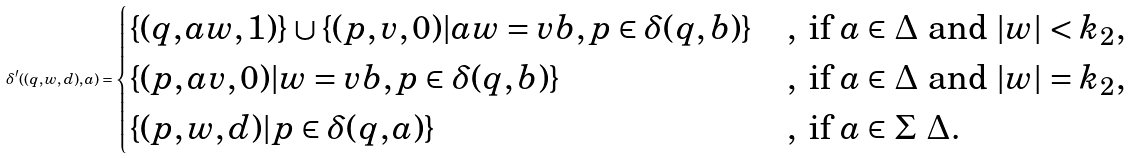<formula> <loc_0><loc_0><loc_500><loc_500>\delta ^ { \prime } ( ( q , w , d ) , a ) = \begin{cases} \{ ( q , a w , 1 ) \} \cup \{ ( p , v , 0 ) | a w = v b , p \in \delta ( q , b ) \} & , \text { if } a \in \Delta \text { and } | w | < k _ { 2 } , \\ \{ ( p , a v , 0 ) | w = v b , p \in \delta ( q , b ) \} & , \text { if } a \in \Delta \text { and } | w | = k _ { 2 } , \\ \{ ( p , w , d ) | p \in \delta ( q , a ) \} & , \text { if } a \in \Sigma \ \Delta . \end{cases}</formula> 